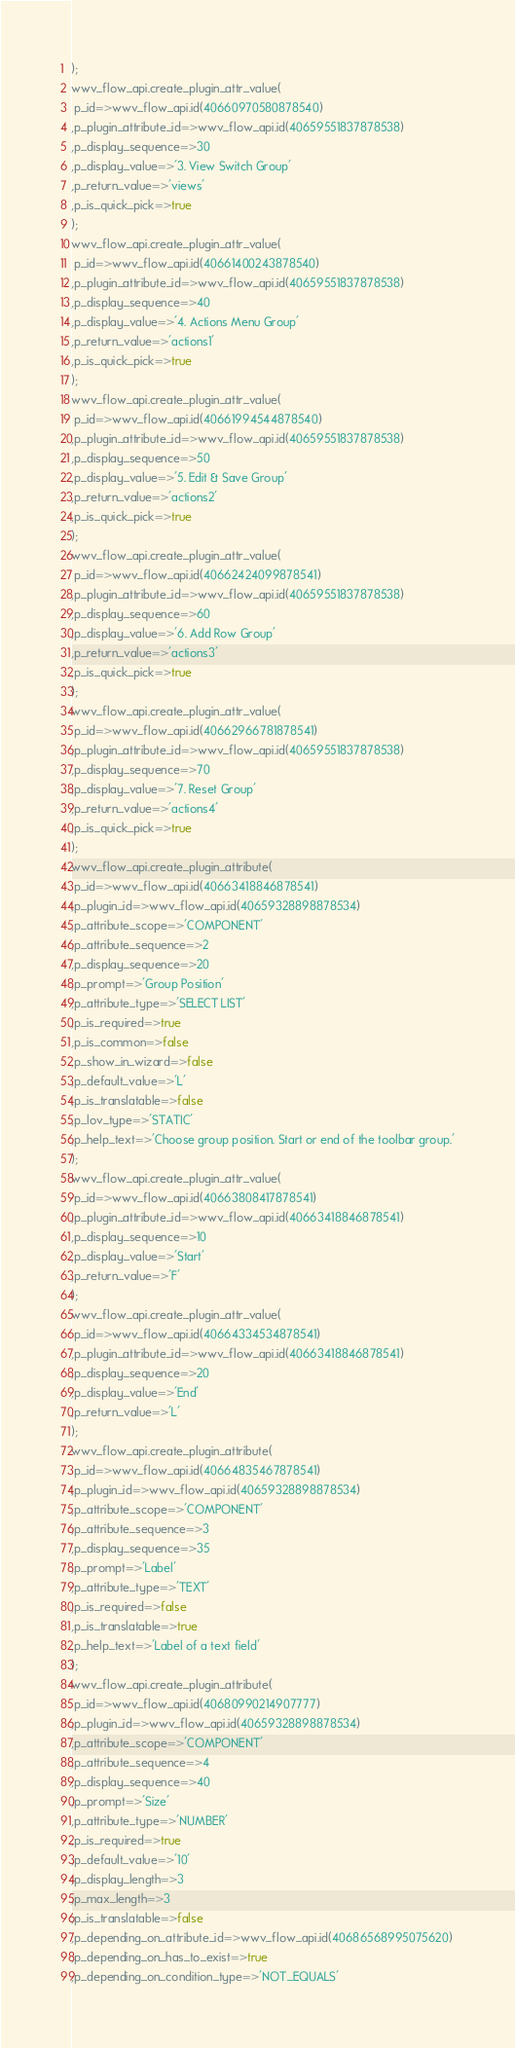<code> <loc_0><loc_0><loc_500><loc_500><_SQL_>);
wwv_flow_api.create_plugin_attr_value(
 p_id=>wwv_flow_api.id(40660970580878540)
,p_plugin_attribute_id=>wwv_flow_api.id(40659551837878538)
,p_display_sequence=>30
,p_display_value=>'3. View Switch Group'
,p_return_value=>'views'
,p_is_quick_pick=>true
);
wwv_flow_api.create_plugin_attr_value(
 p_id=>wwv_flow_api.id(40661400243878540)
,p_plugin_attribute_id=>wwv_flow_api.id(40659551837878538)
,p_display_sequence=>40
,p_display_value=>'4. Actions Menu Group'
,p_return_value=>'actions1'
,p_is_quick_pick=>true
);
wwv_flow_api.create_plugin_attr_value(
 p_id=>wwv_flow_api.id(40661994544878540)
,p_plugin_attribute_id=>wwv_flow_api.id(40659551837878538)
,p_display_sequence=>50
,p_display_value=>'5. Edit & Save Group'
,p_return_value=>'actions2'
,p_is_quick_pick=>true
);
wwv_flow_api.create_plugin_attr_value(
 p_id=>wwv_flow_api.id(40662424099878541)
,p_plugin_attribute_id=>wwv_flow_api.id(40659551837878538)
,p_display_sequence=>60
,p_display_value=>'6. Add Row Group'
,p_return_value=>'actions3'
,p_is_quick_pick=>true
);
wwv_flow_api.create_plugin_attr_value(
 p_id=>wwv_flow_api.id(40662966781878541)
,p_plugin_attribute_id=>wwv_flow_api.id(40659551837878538)
,p_display_sequence=>70
,p_display_value=>'7. Reset Group'
,p_return_value=>'actions4'
,p_is_quick_pick=>true
);
wwv_flow_api.create_plugin_attribute(
 p_id=>wwv_flow_api.id(40663418846878541)
,p_plugin_id=>wwv_flow_api.id(40659328898878534)
,p_attribute_scope=>'COMPONENT'
,p_attribute_sequence=>2
,p_display_sequence=>20
,p_prompt=>'Group Position'
,p_attribute_type=>'SELECT LIST'
,p_is_required=>true
,p_is_common=>false
,p_show_in_wizard=>false
,p_default_value=>'L'
,p_is_translatable=>false
,p_lov_type=>'STATIC'
,p_help_text=>'Choose group position. Start or end of the toolbar group.'
);
wwv_flow_api.create_plugin_attr_value(
 p_id=>wwv_flow_api.id(40663808417878541)
,p_plugin_attribute_id=>wwv_flow_api.id(40663418846878541)
,p_display_sequence=>10
,p_display_value=>'Start'
,p_return_value=>'F'
);
wwv_flow_api.create_plugin_attr_value(
 p_id=>wwv_flow_api.id(40664334534878541)
,p_plugin_attribute_id=>wwv_flow_api.id(40663418846878541)
,p_display_sequence=>20
,p_display_value=>'End'
,p_return_value=>'L'
);
wwv_flow_api.create_plugin_attribute(
 p_id=>wwv_flow_api.id(40664835467878541)
,p_plugin_id=>wwv_flow_api.id(40659328898878534)
,p_attribute_scope=>'COMPONENT'
,p_attribute_sequence=>3
,p_display_sequence=>35
,p_prompt=>'Label'
,p_attribute_type=>'TEXT'
,p_is_required=>false
,p_is_translatable=>true
,p_help_text=>'Label of a text field'
);
wwv_flow_api.create_plugin_attribute(
 p_id=>wwv_flow_api.id(40680990214907777)
,p_plugin_id=>wwv_flow_api.id(40659328898878534)
,p_attribute_scope=>'COMPONENT'
,p_attribute_sequence=>4
,p_display_sequence=>40
,p_prompt=>'Size'
,p_attribute_type=>'NUMBER'
,p_is_required=>true
,p_default_value=>'10'
,p_display_length=>3
,p_max_length=>3
,p_is_translatable=>false
,p_depending_on_attribute_id=>wwv_flow_api.id(40686568995075620)
,p_depending_on_has_to_exist=>true
,p_depending_on_condition_type=>'NOT_EQUALS'</code> 